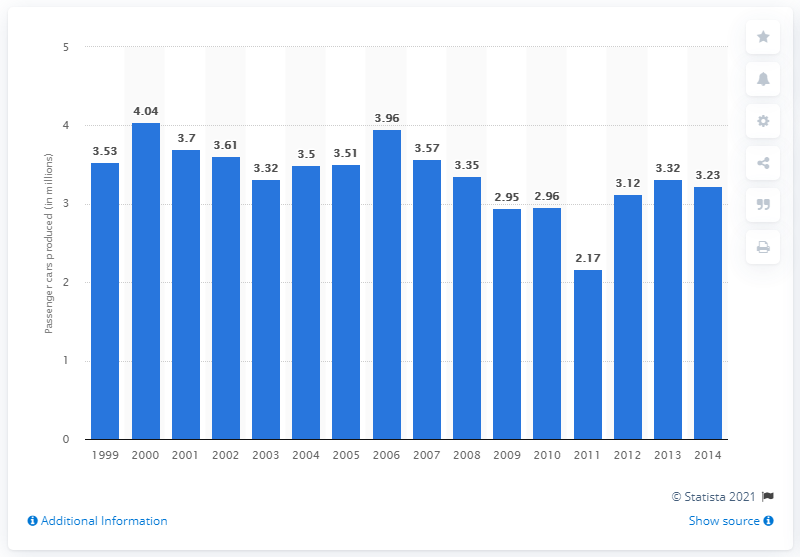Highlight a few significant elements in this photo. Ford produced a total of 3.32 million passenger cars worldwide in 2013. 